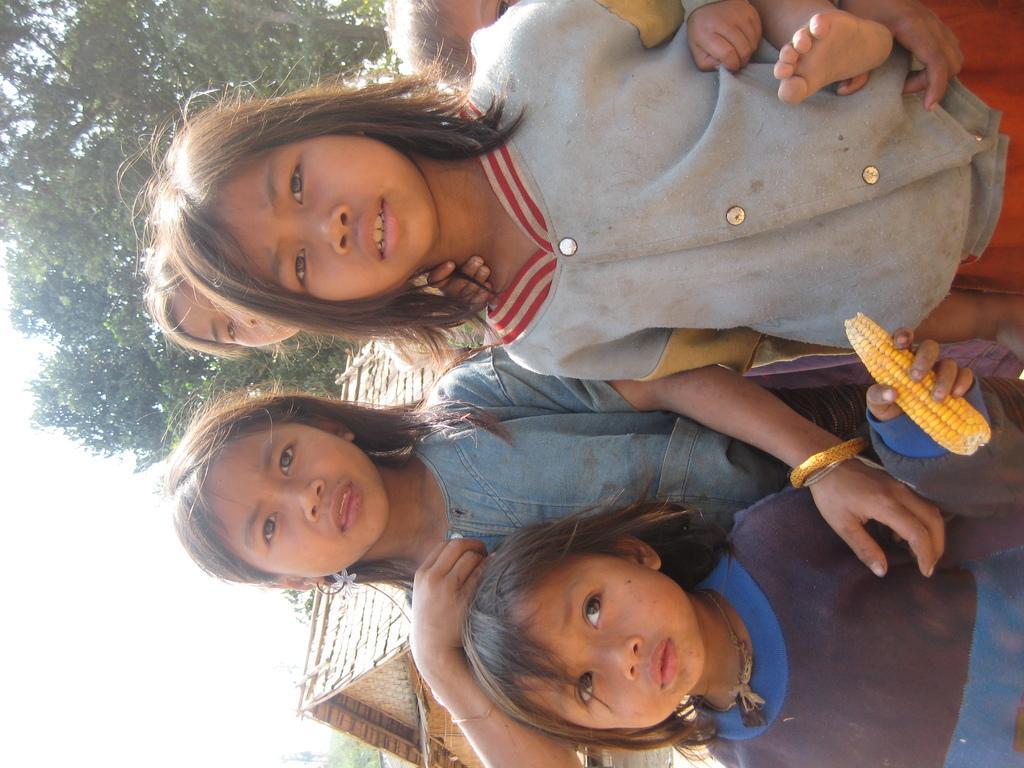Can you describe this image briefly? In this picture we can see group of people, and we can see a girl is holding corn, in the background we can find a hut and few trees. 